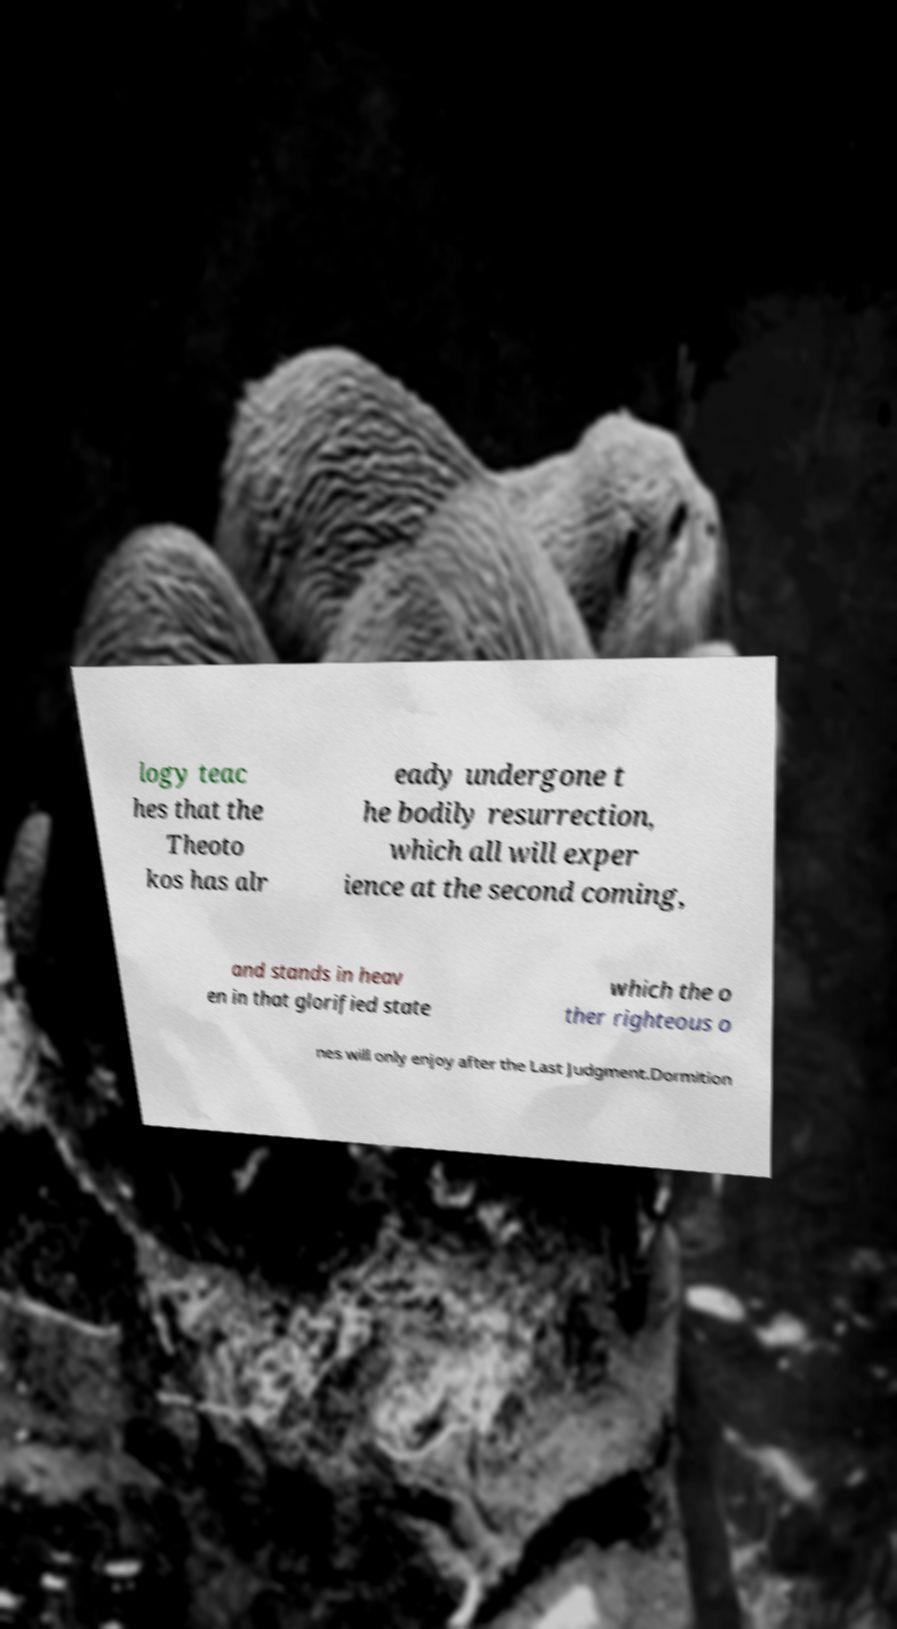There's text embedded in this image that I need extracted. Can you transcribe it verbatim? logy teac hes that the Theoto kos has alr eady undergone t he bodily resurrection, which all will exper ience at the second coming, and stands in heav en in that glorified state which the o ther righteous o nes will only enjoy after the Last Judgment.Dormition 